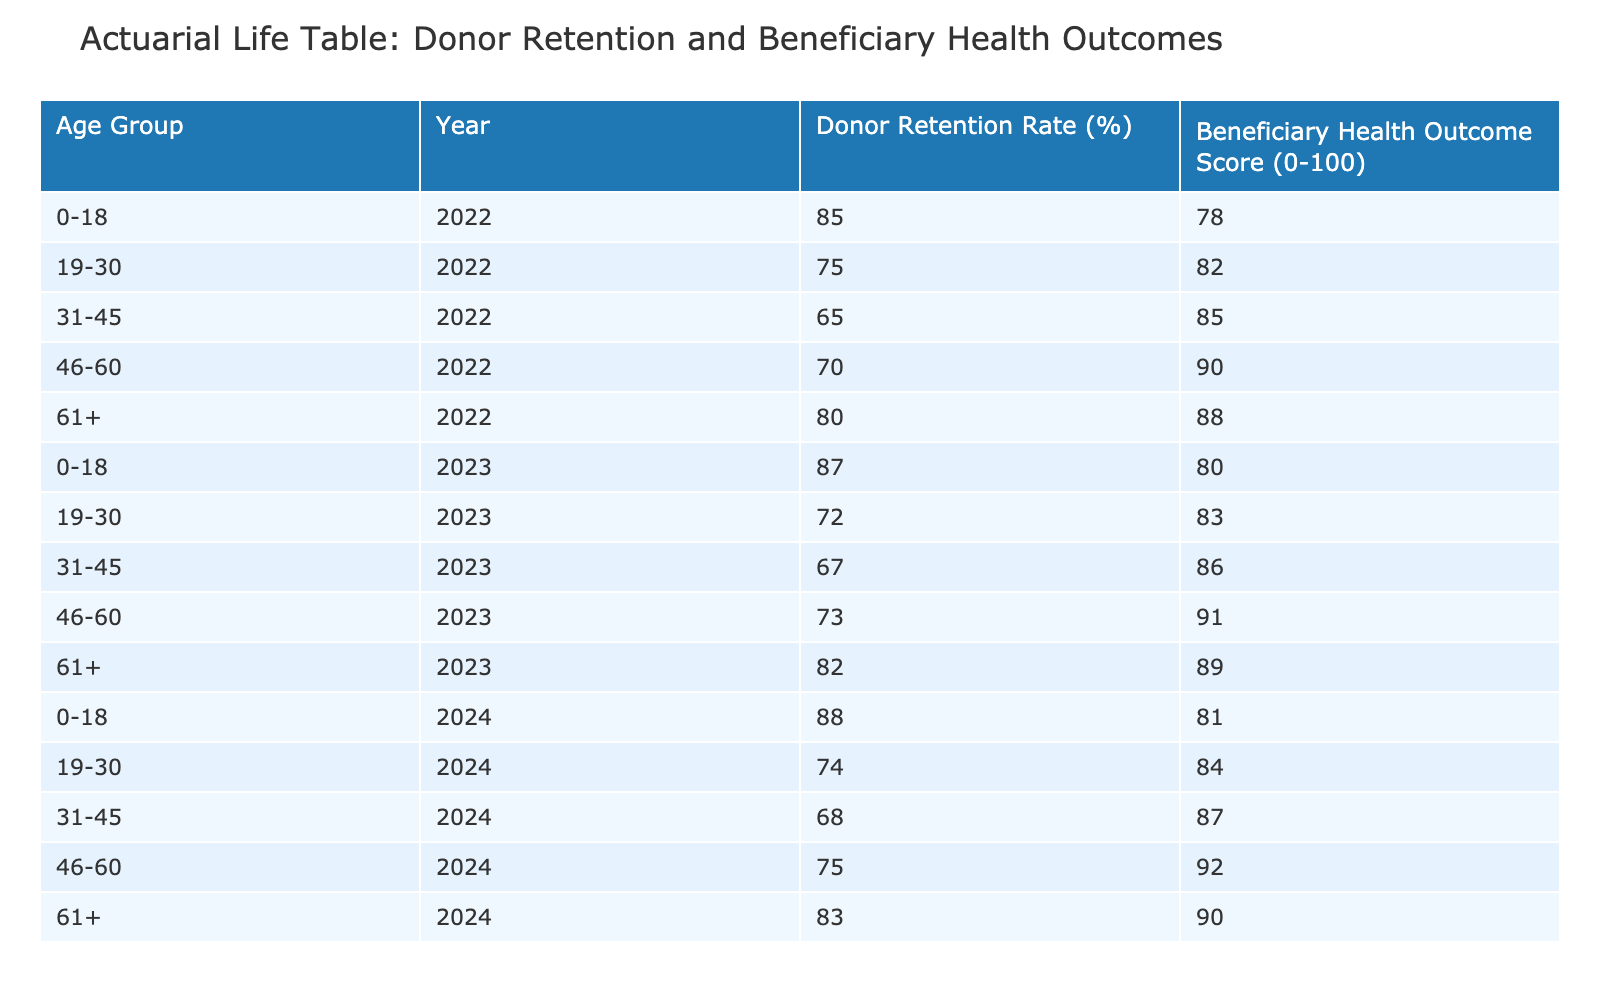What is the donor retention rate for the age group 31-45 in 2023? Looking at the table, I find the row corresponding to the age group 31-45 for the year 2023, which shows a donor retention rate of 67%.
Answer: 67% What is the beneficiary health outcome score for the age group 46-60 in 2024? Referring to the 2024 row for the age group 46-60 in the table, the beneficiary health outcome score is 92.
Answer: 92 What is the average donor retention rate across all age groups in 2022? To find the average, I sum the donor retention rates for the year 2022: (85 + 75 + 65 + 70 + 80) = 375. There are 5 age groups, so the average is 375 / 5 = 75.
Answer: 75 Is the donor retention rate for the age group 19-30 higher in 2022 than in 2023? The table shows a donor retention rate of 75% for 2022 and 72% for 2023 for the age group 19-30. Since 75% is greater than 72%, the statement is true.
Answer: Yes What is the change in the beneficiary health outcome score for the age group 0-18 from 2022 to 2024? The score for the age group 0-18 in 2022 is 78, and in 2024 it is 81. The change is 81 - 78 = 3, indicating an increase in the score.
Answer: 3 Is the donor retention rate for the age group 61+ consistent over the three years? Checking the values for age group 61+ in 2022 (80%), 2023 (82%), and 2024 (83%), I see an increasing trend. Since the rates differ year by year, they are not consistent.
Answer: No What is the highest beneficiary health outcome score in 2023, and for which age group? Reviewing the health outcome scores for 2023, the highest score is 91 for the age group 46-60.
Answer: 91 for 46-60 What is the median donor retention rate across all age groups in 2024? The donor retention rates for 2024 are 88, 74, 68, 75, and 83. Ordering these values: 68, 74, 75, 83, 88, the median (the middle value) is 75.
Answer: 75 What was the overall trend in donor retention rates from 2022 to 2024? To analyze the trend, I observe the retention rates: 85%, 75%, 65%, 70%, 80% for 2022; 87%, 72%, 67%, 73%, 82% for 2023; and 88%, 74%, 68%, 75%, 83% for 2024. Overall, the trend shows a slight decrease over the years, especially in the 19-30, 31-45 age groups.
Answer: Slight decrease 